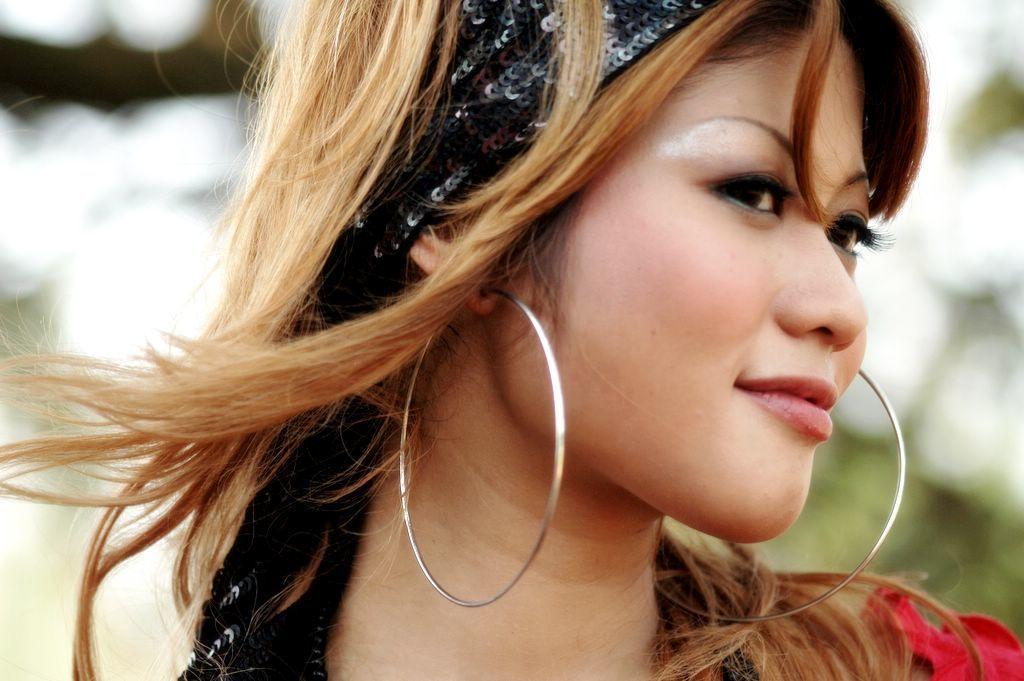Could you give a brief overview of what you see in this image? In this image we can see a woman smiling and the background is blurred. 